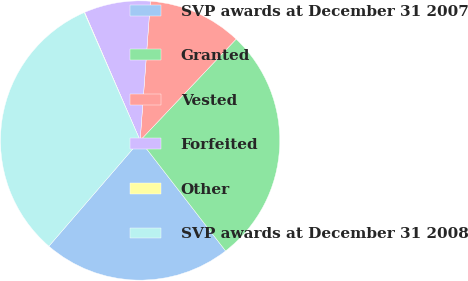<chart> <loc_0><loc_0><loc_500><loc_500><pie_chart><fcel>SVP awards at December 31 2007<fcel>Granted<fcel>Vested<fcel>Forfeited<fcel>Other<fcel>SVP awards at December 31 2008<nl><fcel>21.81%<fcel>27.45%<fcel>10.89%<fcel>7.68%<fcel>0.05%<fcel>32.11%<nl></chart> 